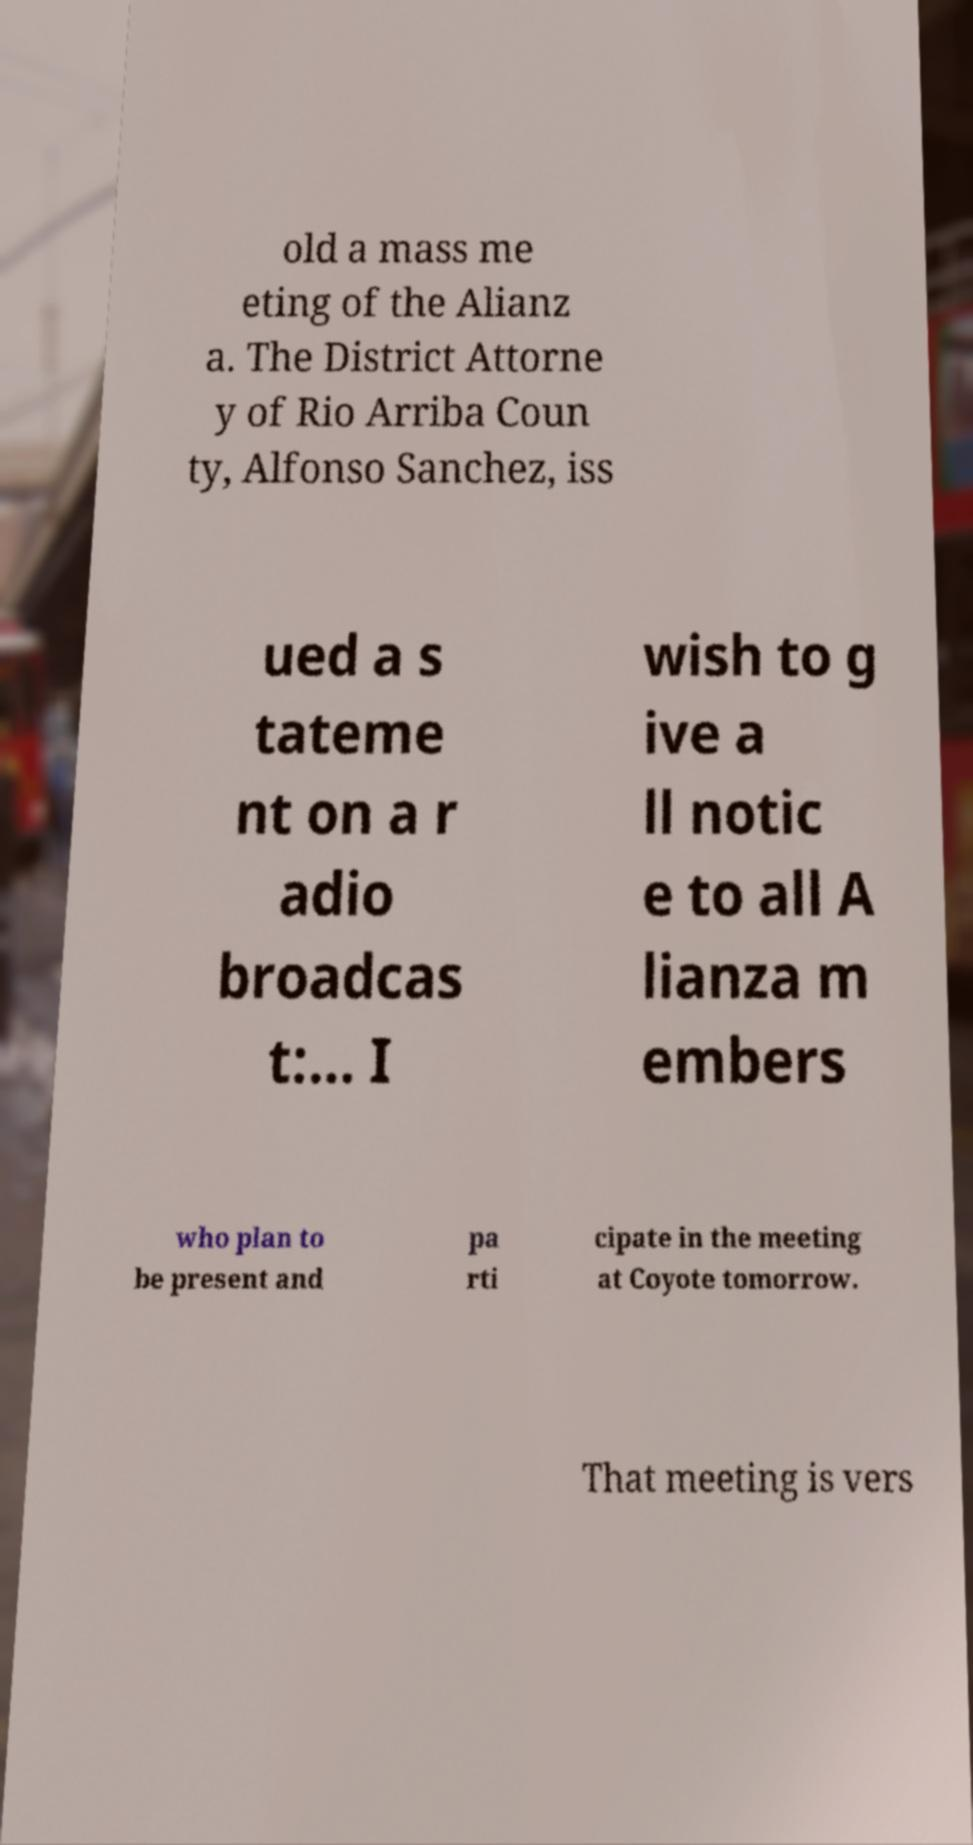Please identify and transcribe the text found in this image. old a mass me eting of the Alianz a. The District Attorne y of Rio Arriba Coun ty, Alfonso Sanchez, iss ued a s tateme nt on a r adio broadcas t:... I wish to g ive a ll notic e to all A lianza m embers who plan to be present and pa rti cipate in the meeting at Coyote tomorrow. That meeting is vers 